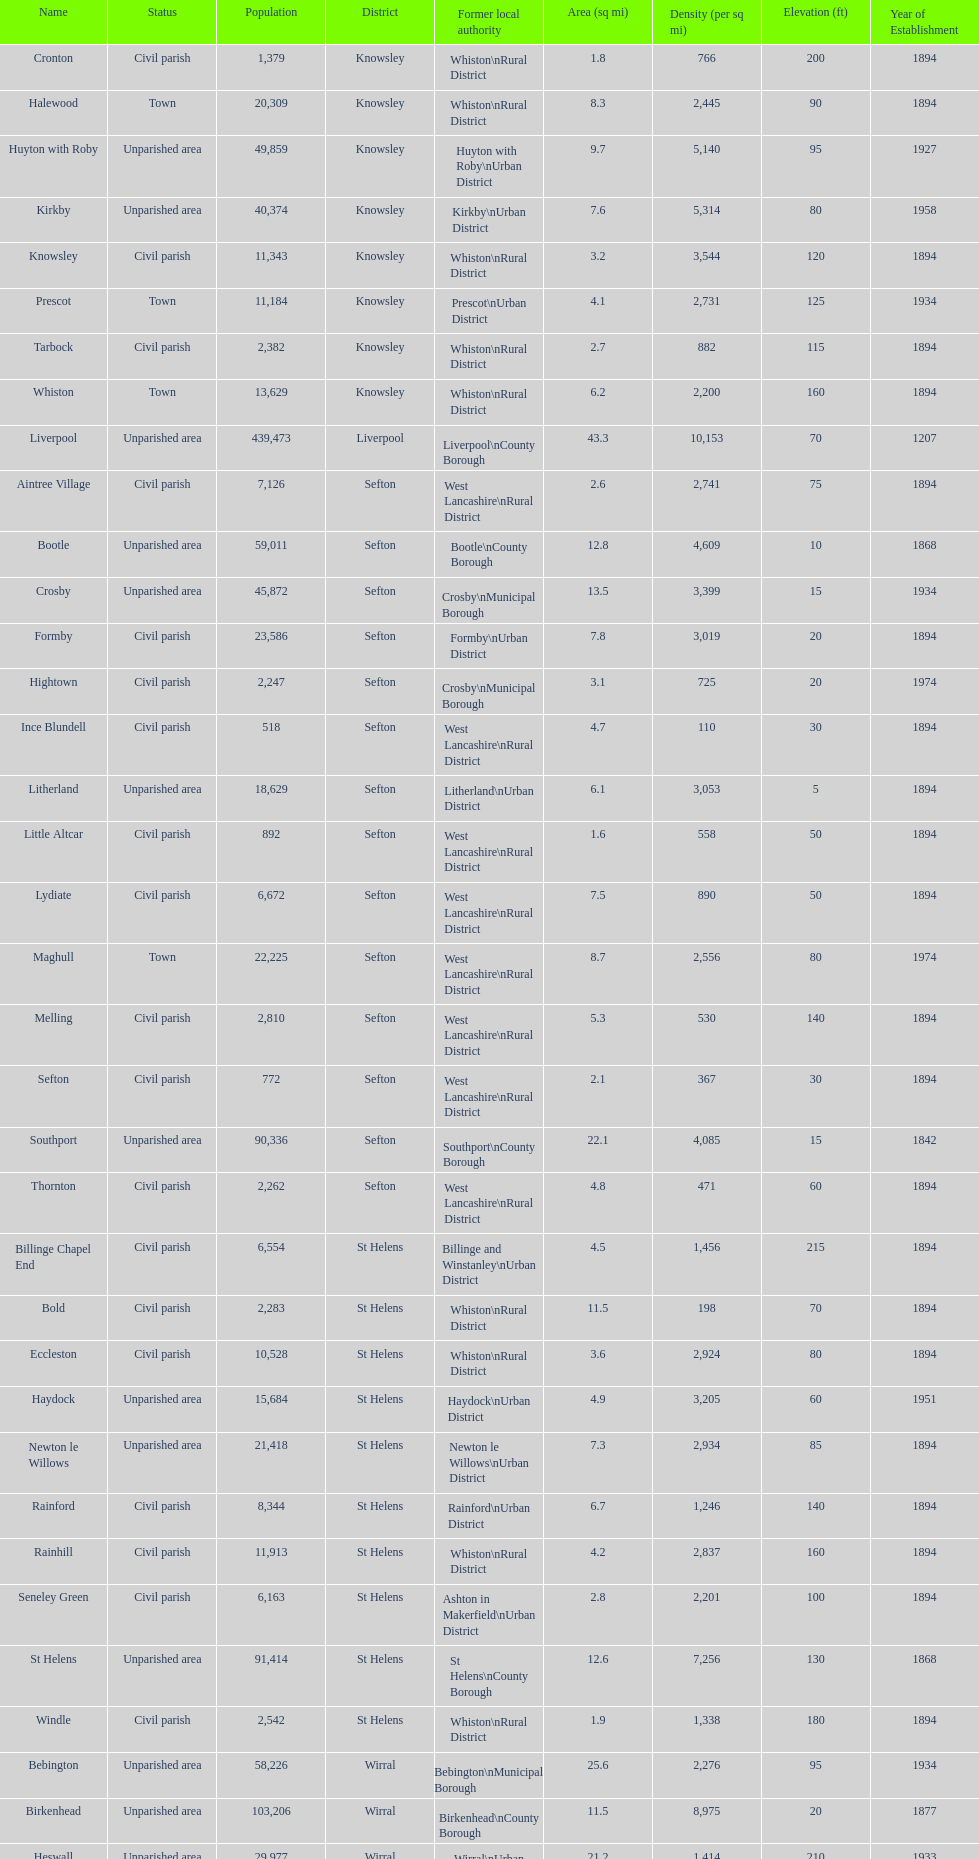What is the number of civil parishes with a population of 10,000 or more? 4. 